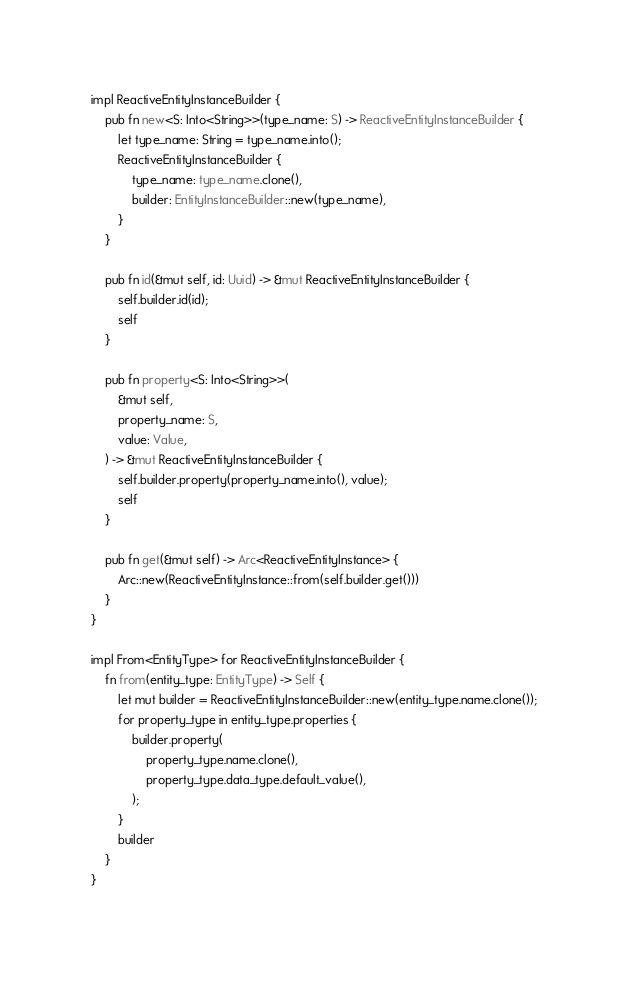Convert code to text. <code><loc_0><loc_0><loc_500><loc_500><_Rust_>impl ReactiveEntityInstanceBuilder {
    pub fn new<S: Into<String>>(type_name: S) -> ReactiveEntityInstanceBuilder {
        let type_name: String = type_name.into();
        ReactiveEntityInstanceBuilder {
            type_name: type_name.clone(),
            builder: EntityInstanceBuilder::new(type_name),
        }
    }

    pub fn id(&mut self, id: Uuid) -> &mut ReactiveEntityInstanceBuilder {
        self.builder.id(id);
        self
    }

    pub fn property<S: Into<String>>(
        &mut self,
        property_name: S,
        value: Value,
    ) -> &mut ReactiveEntityInstanceBuilder {
        self.builder.property(property_name.into(), value);
        self
    }

    pub fn get(&mut self) -> Arc<ReactiveEntityInstance> {
        Arc::new(ReactiveEntityInstance::from(self.builder.get()))
    }
}

impl From<EntityType> for ReactiveEntityInstanceBuilder {
    fn from(entity_type: EntityType) -> Self {
        let mut builder = ReactiveEntityInstanceBuilder::new(entity_type.name.clone());
        for property_type in entity_type.properties {
            builder.property(
                property_type.name.clone(),
                property_type.data_type.default_value(),
            );
        }
        builder
    }
}
</code> 